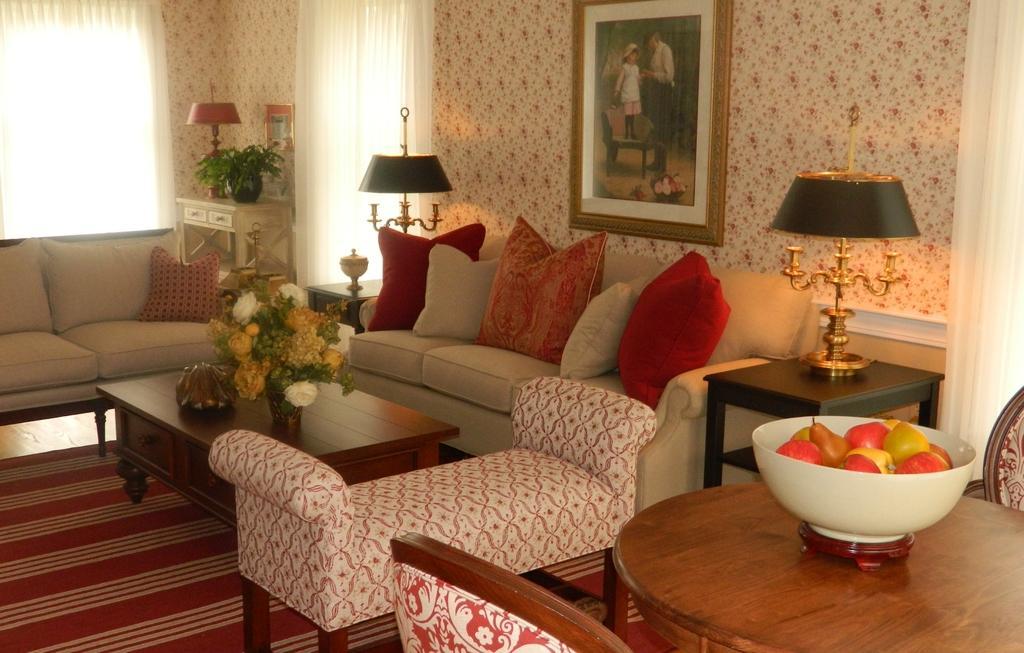How would you summarize this image in a sentence or two? This picture shows a sofa set and flower vase on the table and we see a photo frame on the wall and we see some fruits in the bowl and a plant and couple of curtains to the window 